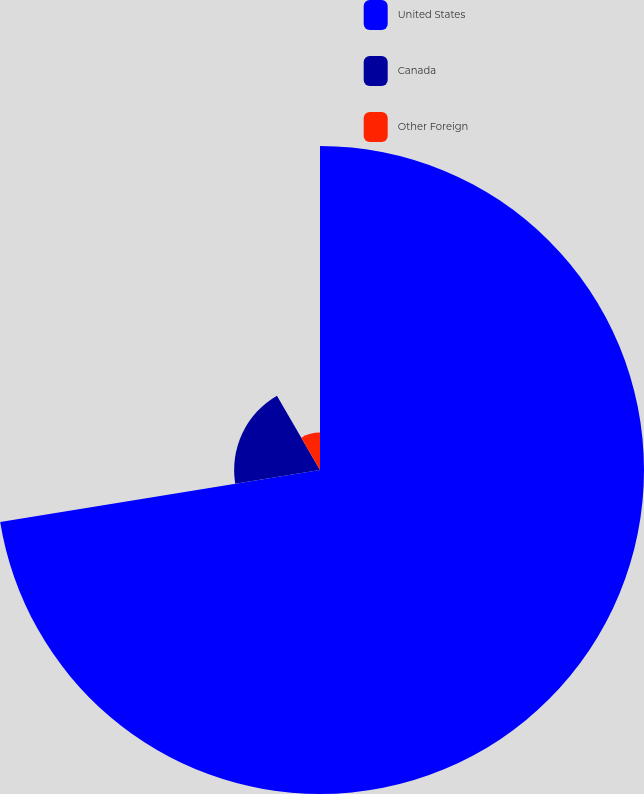<chart> <loc_0><loc_0><loc_500><loc_500><pie_chart><fcel>United States<fcel>Canada<fcel>Other Foreign<nl><fcel>72.44%<fcel>19.2%<fcel>8.36%<nl></chart> 